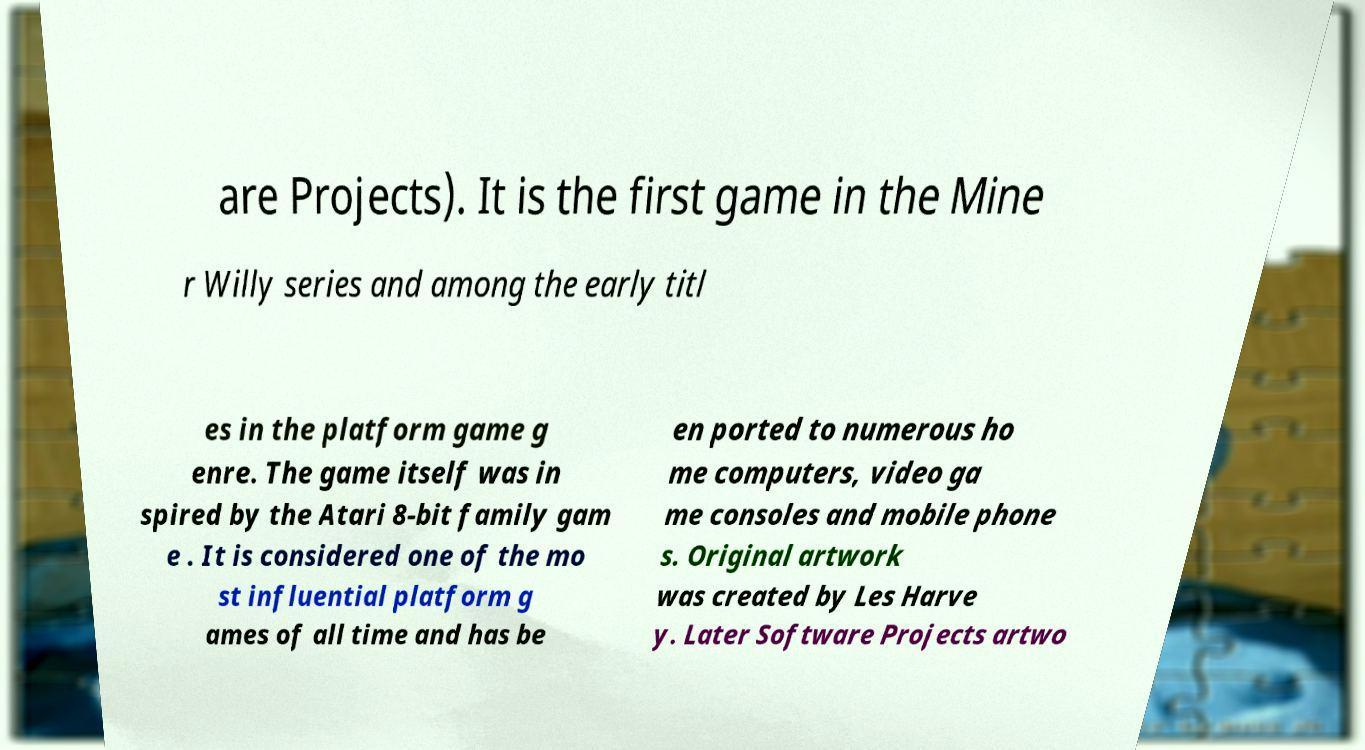Could you extract and type out the text from this image? are Projects). It is the first game in the Mine r Willy series and among the early titl es in the platform game g enre. The game itself was in spired by the Atari 8-bit family gam e . It is considered one of the mo st influential platform g ames of all time and has be en ported to numerous ho me computers, video ga me consoles and mobile phone s. Original artwork was created by Les Harve y. Later Software Projects artwo 